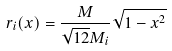Convert formula to latex. <formula><loc_0><loc_0><loc_500><loc_500>\ r _ { i } ( x ) = \frac { M } { \sqrt { 1 2 } M _ { i } } \sqrt { 1 - x ^ { 2 } }</formula> 